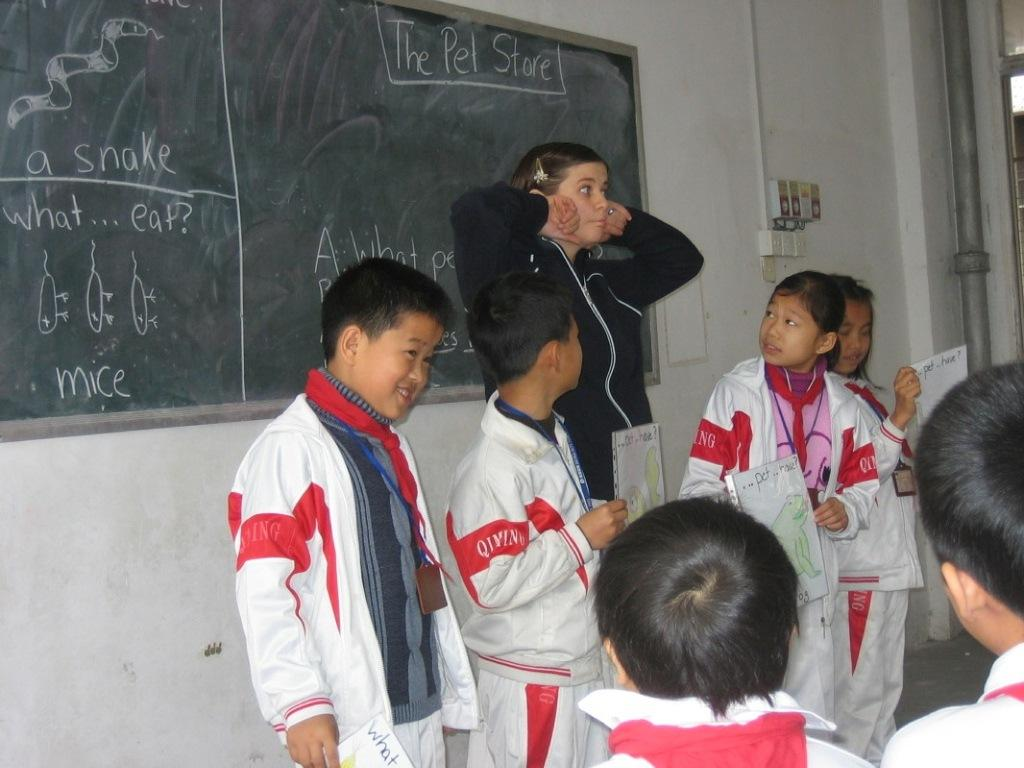<image>
Relay a brief, clear account of the picture shown. Students wearing white jackets that say QIMING on them. 